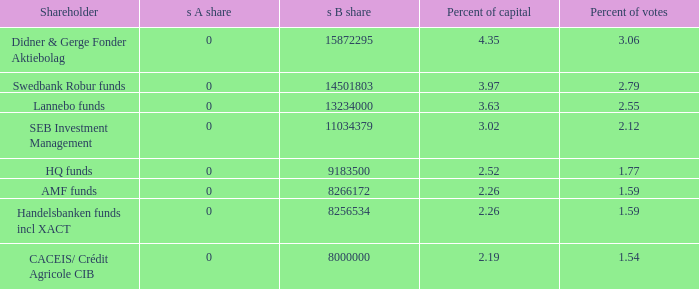55 percent of voting power? 13234000.0. 